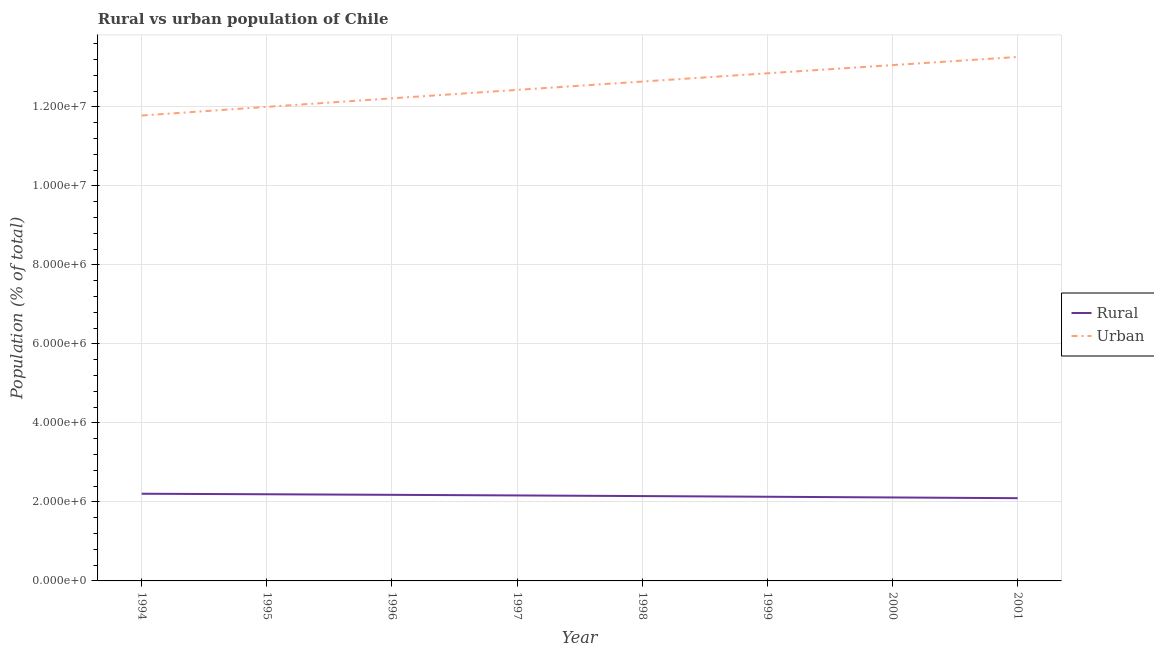How many different coloured lines are there?
Your response must be concise. 2. Does the line corresponding to urban population density intersect with the line corresponding to rural population density?
Provide a short and direct response. No. What is the urban population density in 2001?
Ensure brevity in your answer.  1.33e+07. Across all years, what is the maximum rural population density?
Provide a succinct answer. 2.21e+06. Across all years, what is the minimum urban population density?
Provide a short and direct response. 1.18e+07. In which year was the rural population density minimum?
Your answer should be compact. 2001. What is the total rural population density in the graph?
Your answer should be very brief. 1.72e+07. What is the difference between the urban population density in 1996 and that in 1997?
Make the answer very short. -2.13e+05. What is the difference between the rural population density in 1998 and the urban population density in 1996?
Make the answer very short. -1.01e+07. What is the average urban population density per year?
Your answer should be compact. 1.25e+07. In the year 1995, what is the difference between the urban population density and rural population density?
Offer a terse response. 9.81e+06. What is the ratio of the urban population density in 1999 to that in 2000?
Provide a short and direct response. 0.98. Is the rural population density in 1997 less than that in 1998?
Make the answer very short. No. What is the difference between the highest and the second highest urban population density?
Provide a short and direct response. 2.06e+05. What is the difference between the highest and the lowest urban population density?
Your answer should be compact. 1.48e+06. Is the rural population density strictly greater than the urban population density over the years?
Provide a short and direct response. No. How many years are there in the graph?
Make the answer very short. 8. Does the graph contain any zero values?
Give a very brief answer. No. Does the graph contain grids?
Keep it short and to the point. Yes. Where does the legend appear in the graph?
Your answer should be compact. Center right. What is the title of the graph?
Your answer should be compact. Rural vs urban population of Chile. Does "Residents" appear as one of the legend labels in the graph?
Your answer should be compact. No. What is the label or title of the Y-axis?
Make the answer very short. Population (% of total). What is the Population (% of total) of Rural in 1994?
Your response must be concise. 2.21e+06. What is the Population (% of total) of Urban in 1994?
Make the answer very short. 1.18e+07. What is the Population (% of total) of Rural in 1995?
Your response must be concise. 2.19e+06. What is the Population (% of total) in Urban in 1995?
Your answer should be very brief. 1.20e+07. What is the Population (% of total) of Rural in 1996?
Keep it short and to the point. 2.18e+06. What is the Population (% of total) in Urban in 1996?
Keep it short and to the point. 1.22e+07. What is the Population (% of total) of Rural in 1997?
Provide a short and direct response. 2.16e+06. What is the Population (% of total) of Urban in 1997?
Your response must be concise. 1.24e+07. What is the Population (% of total) in Rural in 1998?
Make the answer very short. 2.15e+06. What is the Population (% of total) of Urban in 1998?
Your answer should be very brief. 1.26e+07. What is the Population (% of total) in Rural in 1999?
Provide a succinct answer. 2.13e+06. What is the Population (% of total) in Urban in 1999?
Offer a very short reply. 1.28e+07. What is the Population (% of total) of Rural in 2000?
Your answer should be compact. 2.11e+06. What is the Population (% of total) of Urban in 2000?
Offer a terse response. 1.31e+07. What is the Population (% of total) in Rural in 2001?
Give a very brief answer. 2.09e+06. What is the Population (% of total) in Urban in 2001?
Your answer should be very brief. 1.33e+07. Across all years, what is the maximum Population (% of total) of Rural?
Provide a succinct answer. 2.21e+06. Across all years, what is the maximum Population (% of total) of Urban?
Give a very brief answer. 1.33e+07. Across all years, what is the minimum Population (% of total) of Rural?
Your answer should be compact. 2.09e+06. Across all years, what is the minimum Population (% of total) in Urban?
Make the answer very short. 1.18e+07. What is the total Population (% of total) of Rural in the graph?
Your answer should be compact. 1.72e+07. What is the total Population (% of total) in Urban in the graph?
Offer a very short reply. 1.00e+08. What is the difference between the Population (% of total) of Rural in 1994 and that in 1995?
Offer a very short reply. 1.32e+04. What is the difference between the Population (% of total) in Urban in 1994 and that in 1995?
Make the answer very short. -2.19e+05. What is the difference between the Population (% of total) in Rural in 1994 and that in 1996?
Your answer should be compact. 2.75e+04. What is the difference between the Population (% of total) of Urban in 1994 and that in 1996?
Offer a very short reply. -4.35e+05. What is the difference between the Population (% of total) in Rural in 1994 and that in 1997?
Give a very brief answer. 4.29e+04. What is the difference between the Population (% of total) in Urban in 1994 and that in 1997?
Make the answer very short. -6.49e+05. What is the difference between the Population (% of total) in Rural in 1994 and that in 1998?
Give a very brief answer. 5.91e+04. What is the difference between the Population (% of total) of Urban in 1994 and that in 1998?
Your answer should be compact. -8.60e+05. What is the difference between the Population (% of total) in Rural in 1994 and that in 1999?
Provide a succinct answer. 7.64e+04. What is the difference between the Population (% of total) of Urban in 1994 and that in 1999?
Give a very brief answer. -1.07e+06. What is the difference between the Population (% of total) of Rural in 1994 and that in 2000?
Provide a succinct answer. 9.41e+04. What is the difference between the Population (% of total) in Urban in 1994 and that in 2000?
Give a very brief answer. -1.28e+06. What is the difference between the Population (% of total) of Rural in 1994 and that in 2001?
Offer a very short reply. 1.12e+05. What is the difference between the Population (% of total) of Urban in 1994 and that in 2001?
Give a very brief answer. -1.48e+06. What is the difference between the Population (% of total) of Rural in 1995 and that in 1996?
Provide a succinct answer. 1.43e+04. What is the difference between the Population (% of total) of Urban in 1995 and that in 1996?
Your response must be concise. -2.16e+05. What is the difference between the Population (% of total) of Rural in 1995 and that in 1997?
Keep it short and to the point. 2.97e+04. What is the difference between the Population (% of total) of Urban in 1995 and that in 1997?
Provide a succinct answer. -4.30e+05. What is the difference between the Population (% of total) in Rural in 1995 and that in 1998?
Provide a succinct answer. 4.59e+04. What is the difference between the Population (% of total) of Urban in 1995 and that in 1998?
Give a very brief answer. -6.41e+05. What is the difference between the Population (% of total) of Rural in 1995 and that in 1999?
Provide a succinct answer. 6.32e+04. What is the difference between the Population (% of total) in Urban in 1995 and that in 1999?
Provide a short and direct response. -8.50e+05. What is the difference between the Population (% of total) of Rural in 1995 and that in 2000?
Your answer should be very brief. 8.09e+04. What is the difference between the Population (% of total) in Urban in 1995 and that in 2000?
Offer a very short reply. -1.06e+06. What is the difference between the Population (% of total) of Rural in 1995 and that in 2001?
Ensure brevity in your answer.  9.93e+04. What is the difference between the Population (% of total) of Urban in 1995 and that in 2001?
Give a very brief answer. -1.26e+06. What is the difference between the Population (% of total) of Rural in 1996 and that in 1997?
Offer a terse response. 1.54e+04. What is the difference between the Population (% of total) in Urban in 1996 and that in 1997?
Offer a terse response. -2.13e+05. What is the difference between the Population (% of total) of Rural in 1996 and that in 1998?
Your response must be concise. 3.17e+04. What is the difference between the Population (% of total) of Urban in 1996 and that in 1998?
Keep it short and to the point. -4.24e+05. What is the difference between the Population (% of total) in Rural in 1996 and that in 1999?
Make the answer very short. 4.89e+04. What is the difference between the Population (% of total) of Urban in 1996 and that in 1999?
Keep it short and to the point. -6.33e+05. What is the difference between the Population (% of total) in Rural in 1996 and that in 2000?
Your answer should be very brief. 6.66e+04. What is the difference between the Population (% of total) in Urban in 1996 and that in 2000?
Ensure brevity in your answer.  -8.41e+05. What is the difference between the Population (% of total) of Rural in 1996 and that in 2001?
Offer a very short reply. 8.50e+04. What is the difference between the Population (% of total) of Urban in 1996 and that in 2001?
Your answer should be very brief. -1.05e+06. What is the difference between the Population (% of total) of Rural in 1997 and that in 1998?
Provide a succinct answer. 1.63e+04. What is the difference between the Population (% of total) in Urban in 1997 and that in 1998?
Provide a succinct answer. -2.11e+05. What is the difference between the Population (% of total) of Rural in 1997 and that in 1999?
Offer a very short reply. 3.35e+04. What is the difference between the Population (% of total) of Urban in 1997 and that in 1999?
Provide a short and direct response. -4.20e+05. What is the difference between the Population (% of total) of Rural in 1997 and that in 2000?
Provide a short and direct response. 5.12e+04. What is the difference between the Population (% of total) of Urban in 1997 and that in 2000?
Provide a succinct answer. -6.28e+05. What is the difference between the Population (% of total) in Rural in 1997 and that in 2001?
Keep it short and to the point. 6.96e+04. What is the difference between the Population (% of total) in Urban in 1997 and that in 2001?
Offer a very short reply. -8.34e+05. What is the difference between the Population (% of total) of Rural in 1998 and that in 1999?
Provide a short and direct response. 1.72e+04. What is the difference between the Population (% of total) of Urban in 1998 and that in 1999?
Provide a succinct answer. -2.09e+05. What is the difference between the Population (% of total) in Rural in 1998 and that in 2000?
Give a very brief answer. 3.50e+04. What is the difference between the Population (% of total) in Urban in 1998 and that in 2000?
Offer a very short reply. -4.17e+05. What is the difference between the Population (% of total) of Rural in 1998 and that in 2001?
Give a very brief answer. 5.33e+04. What is the difference between the Population (% of total) of Urban in 1998 and that in 2001?
Make the answer very short. -6.23e+05. What is the difference between the Population (% of total) of Rural in 1999 and that in 2000?
Make the answer very short. 1.77e+04. What is the difference between the Population (% of total) of Urban in 1999 and that in 2000?
Ensure brevity in your answer.  -2.08e+05. What is the difference between the Population (% of total) in Rural in 1999 and that in 2001?
Provide a short and direct response. 3.61e+04. What is the difference between the Population (% of total) of Urban in 1999 and that in 2001?
Make the answer very short. -4.14e+05. What is the difference between the Population (% of total) in Rural in 2000 and that in 2001?
Ensure brevity in your answer.  1.84e+04. What is the difference between the Population (% of total) in Urban in 2000 and that in 2001?
Offer a terse response. -2.06e+05. What is the difference between the Population (% of total) of Rural in 1994 and the Population (% of total) of Urban in 1995?
Provide a short and direct response. -9.79e+06. What is the difference between the Population (% of total) in Rural in 1994 and the Population (% of total) in Urban in 1996?
Your answer should be very brief. -1.00e+07. What is the difference between the Population (% of total) of Rural in 1994 and the Population (% of total) of Urban in 1997?
Your answer should be very brief. -1.02e+07. What is the difference between the Population (% of total) in Rural in 1994 and the Population (% of total) in Urban in 1998?
Your answer should be very brief. -1.04e+07. What is the difference between the Population (% of total) in Rural in 1994 and the Population (% of total) in Urban in 1999?
Provide a succinct answer. -1.06e+07. What is the difference between the Population (% of total) in Rural in 1994 and the Population (% of total) in Urban in 2000?
Provide a succinct answer. -1.09e+07. What is the difference between the Population (% of total) in Rural in 1994 and the Population (% of total) in Urban in 2001?
Keep it short and to the point. -1.11e+07. What is the difference between the Population (% of total) of Rural in 1995 and the Population (% of total) of Urban in 1996?
Make the answer very short. -1.00e+07. What is the difference between the Population (% of total) of Rural in 1995 and the Population (% of total) of Urban in 1997?
Your answer should be compact. -1.02e+07. What is the difference between the Population (% of total) of Rural in 1995 and the Population (% of total) of Urban in 1998?
Provide a short and direct response. -1.04e+07. What is the difference between the Population (% of total) of Rural in 1995 and the Population (% of total) of Urban in 1999?
Your answer should be very brief. -1.07e+07. What is the difference between the Population (% of total) in Rural in 1995 and the Population (% of total) in Urban in 2000?
Your response must be concise. -1.09e+07. What is the difference between the Population (% of total) of Rural in 1995 and the Population (% of total) of Urban in 2001?
Ensure brevity in your answer.  -1.11e+07. What is the difference between the Population (% of total) in Rural in 1996 and the Population (% of total) in Urban in 1997?
Your answer should be very brief. -1.03e+07. What is the difference between the Population (% of total) in Rural in 1996 and the Population (% of total) in Urban in 1998?
Your response must be concise. -1.05e+07. What is the difference between the Population (% of total) in Rural in 1996 and the Population (% of total) in Urban in 1999?
Make the answer very short. -1.07e+07. What is the difference between the Population (% of total) of Rural in 1996 and the Population (% of total) of Urban in 2000?
Your answer should be compact. -1.09e+07. What is the difference between the Population (% of total) in Rural in 1996 and the Population (% of total) in Urban in 2001?
Your answer should be very brief. -1.11e+07. What is the difference between the Population (% of total) of Rural in 1997 and the Population (% of total) of Urban in 1998?
Your answer should be very brief. -1.05e+07. What is the difference between the Population (% of total) in Rural in 1997 and the Population (% of total) in Urban in 1999?
Offer a terse response. -1.07e+07. What is the difference between the Population (% of total) of Rural in 1997 and the Population (% of total) of Urban in 2000?
Provide a succinct answer. -1.09e+07. What is the difference between the Population (% of total) of Rural in 1997 and the Population (% of total) of Urban in 2001?
Ensure brevity in your answer.  -1.11e+07. What is the difference between the Population (% of total) of Rural in 1998 and the Population (% of total) of Urban in 1999?
Your response must be concise. -1.07e+07. What is the difference between the Population (% of total) in Rural in 1998 and the Population (% of total) in Urban in 2000?
Offer a terse response. -1.09e+07. What is the difference between the Population (% of total) in Rural in 1998 and the Population (% of total) in Urban in 2001?
Make the answer very short. -1.11e+07. What is the difference between the Population (% of total) of Rural in 1999 and the Population (% of total) of Urban in 2000?
Make the answer very short. -1.09e+07. What is the difference between the Population (% of total) in Rural in 1999 and the Population (% of total) in Urban in 2001?
Your response must be concise. -1.11e+07. What is the difference between the Population (% of total) in Rural in 2000 and the Population (% of total) in Urban in 2001?
Offer a terse response. -1.12e+07. What is the average Population (% of total) in Rural per year?
Provide a succinct answer. 2.15e+06. What is the average Population (% of total) in Urban per year?
Your answer should be very brief. 1.25e+07. In the year 1994, what is the difference between the Population (% of total) in Rural and Population (% of total) in Urban?
Provide a short and direct response. -9.57e+06. In the year 1995, what is the difference between the Population (% of total) in Rural and Population (% of total) in Urban?
Your answer should be very brief. -9.81e+06. In the year 1996, what is the difference between the Population (% of total) in Rural and Population (% of total) in Urban?
Provide a succinct answer. -1.00e+07. In the year 1997, what is the difference between the Population (% of total) in Rural and Population (% of total) in Urban?
Your answer should be compact. -1.03e+07. In the year 1998, what is the difference between the Population (% of total) in Rural and Population (% of total) in Urban?
Provide a succinct answer. -1.05e+07. In the year 1999, what is the difference between the Population (% of total) in Rural and Population (% of total) in Urban?
Provide a short and direct response. -1.07e+07. In the year 2000, what is the difference between the Population (% of total) of Rural and Population (% of total) of Urban?
Offer a terse response. -1.09e+07. In the year 2001, what is the difference between the Population (% of total) of Rural and Population (% of total) of Urban?
Your response must be concise. -1.12e+07. What is the ratio of the Population (% of total) of Urban in 1994 to that in 1995?
Your response must be concise. 0.98. What is the ratio of the Population (% of total) of Rural in 1994 to that in 1996?
Provide a succinct answer. 1.01. What is the ratio of the Population (% of total) in Urban in 1994 to that in 1996?
Keep it short and to the point. 0.96. What is the ratio of the Population (% of total) in Rural in 1994 to that in 1997?
Offer a very short reply. 1.02. What is the ratio of the Population (% of total) of Urban in 1994 to that in 1997?
Offer a very short reply. 0.95. What is the ratio of the Population (% of total) of Rural in 1994 to that in 1998?
Provide a short and direct response. 1.03. What is the ratio of the Population (% of total) in Urban in 1994 to that in 1998?
Your response must be concise. 0.93. What is the ratio of the Population (% of total) of Rural in 1994 to that in 1999?
Your answer should be very brief. 1.04. What is the ratio of the Population (% of total) of Urban in 1994 to that in 1999?
Make the answer very short. 0.92. What is the ratio of the Population (% of total) of Rural in 1994 to that in 2000?
Give a very brief answer. 1.04. What is the ratio of the Population (% of total) of Urban in 1994 to that in 2000?
Your answer should be compact. 0.9. What is the ratio of the Population (% of total) in Rural in 1994 to that in 2001?
Ensure brevity in your answer.  1.05. What is the ratio of the Population (% of total) of Urban in 1994 to that in 2001?
Provide a succinct answer. 0.89. What is the ratio of the Population (% of total) of Urban in 1995 to that in 1996?
Make the answer very short. 0.98. What is the ratio of the Population (% of total) of Rural in 1995 to that in 1997?
Offer a terse response. 1.01. What is the ratio of the Population (% of total) in Urban in 1995 to that in 1997?
Make the answer very short. 0.97. What is the ratio of the Population (% of total) of Rural in 1995 to that in 1998?
Your answer should be compact. 1.02. What is the ratio of the Population (% of total) of Urban in 1995 to that in 1998?
Ensure brevity in your answer.  0.95. What is the ratio of the Population (% of total) in Rural in 1995 to that in 1999?
Provide a short and direct response. 1.03. What is the ratio of the Population (% of total) in Urban in 1995 to that in 1999?
Offer a very short reply. 0.93. What is the ratio of the Population (% of total) of Rural in 1995 to that in 2000?
Provide a succinct answer. 1.04. What is the ratio of the Population (% of total) in Urban in 1995 to that in 2000?
Your answer should be very brief. 0.92. What is the ratio of the Population (% of total) of Rural in 1995 to that in 2001?
Provide a succinct answer. 1.05. What is the ratio of the Population (% of total) in Urban in 1995 to that in 2001?
Ensure brevity in your answer.  0.9. What is the ratio of the Population (% of total) in Rural in 1996 to that in 1997?
Make the answer very short. 1.01. What is the ratio of the Population (% of total) of Urban in 1996 to that in 1997?
Make the answer very short. 0.98. What is the ratio of the Population (% of total) in Rural in 1996 to that in 1998?
Your answer should be very brief. 1.01. What is the ratio of the Population (% of total) in Urban in 1996 to that in 1998?
Make the answer very short. 0.97. What is the ratio of the Population (% of total) of Rural in 1996 to that in 1999?
Your answer should be very brief. 1.02. What is the ratio of the Population (% of total) in Urban in 1996 to that in 1999?
Keep it short and to the point. 0.95. What is the ratio of the Population (% of total) in Rural in 1996 to that in 2000?
Provide a succinct answer. 1.03. What is the ratio of the Population (% of total) in Urban in 1996 to that in 2000?
Provide a short and direct response. 0.94. What is the ratio of the Population (% of total) in Rural in 1996 to that in 2001?
Offer a very short reply. 1.04. What is the ratio of the Population (% of total) in Urban in 1996 to that in 2001?
Your answer should be very brief. 0.92. What is the ratio of the Population (% of total) of Rural in 1997 to that in 1998?
Provide a short and direct response. 1.01. What is the ratio of the Population (% of total) in Urban in 1997 to that in 1998?
Make the answer very short. 0.98. What is the ratio of the Population (% of total) of Rural in 1997 to that in 1999?
Provide a succinct answer. 1.02. What is the ratio of the Population (% of total) of Urban in 1997 to that in 1999?
Provide a succinct answer. 0.97. What is the ratio of the Population (% of total) in Rural in 1997 to that in 2000?
Keep it short and to the point. 1.02. What is the ratio of the Population (% of total) in Urban in 1997 to that in 2000?
Offer a terse response. 0.95. What is the ratio of the Population (% of total) in Rural in 1997 to that in 2001?
Keep it short and to the point. 1.03. What is the ratio of the Population (% of total) of Urban in 1997 to that in 2001?
Provide a short and direct response. 0.94. What is the ratio of the Population (% of total) in Rural in 1998 to that in 1999?
Offer a terse response. 1.01. What is the ratio of the Population (% of total) in Urban in 1998 to that in 1999?
Ensure brevity in your answer.  0.98. What is the ratio of the Population (% of total) in Rural in 1998 to that in 2000?
Keep it short and to the point. 1.02. What is the ratio of the Population (% of total) of Urban in 1998 to that in 2000?
Make the answer very short. 0.97. What is the ratio of the Population (% of total) of Rural in 1998 to that in 2001?
Your response must be concise. 1.03. What is the ratio of the Population (% of total) in Urban in 1998 to that in 2001?
Provide a succinct answer. 0.95. What is the ratio of the Population (% of total) in Rural in 1999 to that in 2000?
Ensure brevity in your answer.  1.01. What is the ratio of the Population (% of total) of Urban in 1999 to that in 2000?
Provide a succinct answer. 0.98. What is the ratio of the Population (% of total) of Rural in 1999 to that in 2001?
Offer a very short reply. 1.02. What is the ratio of the Population (% of total) of Urban in 1999 to that in 2001?
Your answer should be very brief. 0.97. What is the ratio of the Population (% of total) in Rural in 2000 to that in 2001?
Offer a terse response. 1.01. What is the ratio of the Population (% of total) of Urban in 2000 to that in 2001?
Your answer should be compact. 0.98. What is the difference between the highest and the second highest Population (% of total) of Rural?
Ensure brevity in your answer.  1.32e+04. What is the difference between the highest and the second highest Population (% of total) of Urban?
Your answer should be very brief. 2.06e+05. What is the difference between the highest and the lowest Population (% of total) in Rural?
Your response must be concise. 1.12e+05. What is the difference between the highest and the lowest Population (% of total) of Urban?
Ensure brevity in your answer.  1.48e+06. 